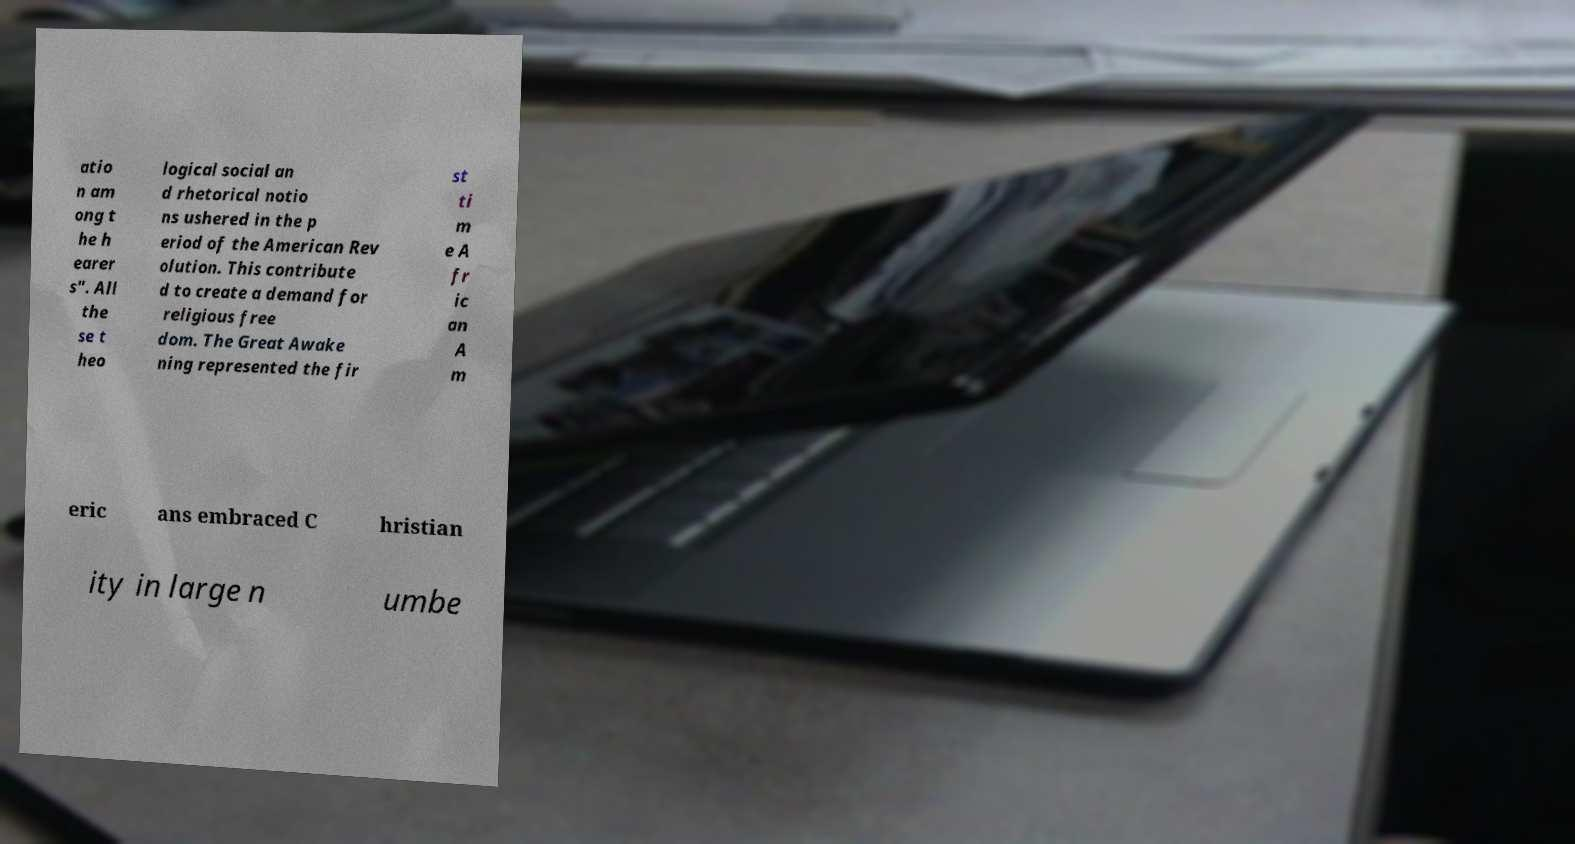I need the written content from this picture converted into text. Can you do that? atio n am ong t he h earer s". All the se t heo logical social an d rhetorical notio ns ushered in the p eriod of the American Rev olution. This contribute d to create a demand for religious free dom. The Great Awake ning represented the fir st ti m e A fr ic an A m eric ans embraced C hristian ity in large n umbe 